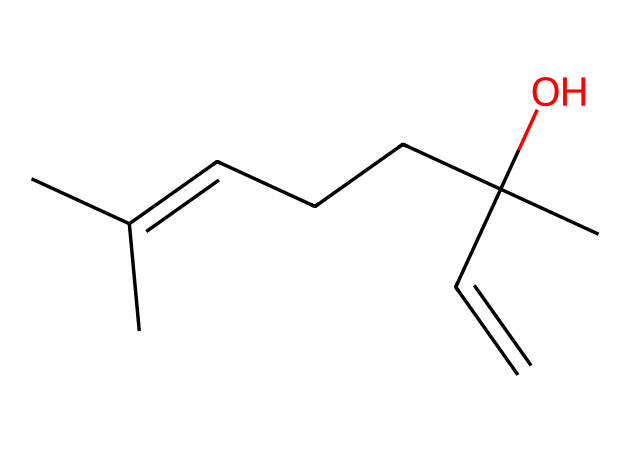What is the molecular formula of geraniol? By examining the SMILES representation, we can identify the number of carbon (C), hydrogen (H), and oxygen (O) atoms present in the structure. The total counts indicate a molecular formula of C10H18O.
Answer: C10H18O How many carbon atoms are in geraniol? The SMILES representation shows ten carbon atoms (C) through visual counting of the 'C' characters present in the structure.
Answer: 10 Is geraniol a saturated or unsaturated compound? The presence of a double bond (C=C) in the structure indicates that geraniol is unsaturated, as unsaturated compounds contain at least one double bond.
Answer: unsaturated What functional group is present in geraniol? The hydroxyl group (-OH) attached to a carbon atom indicates that geraniol is an alcohol, as this functional group characterizes alcohol compounds.
Answer: alcohol How many chiral centers does geraniol have? Analyzing the molecular structure reveals one carbon atom that has four different substituents, indicating one chiral center in geraniol.
Answer: 1 Which class of compounds does geraniol belong to? As indicated by its structure and the presence of multiple double bonds and an alcohol group, geraniol is classified under terpenes, which are characterized by their specific carbon skeletons derived from isoprene units.
Answer: terpenes 